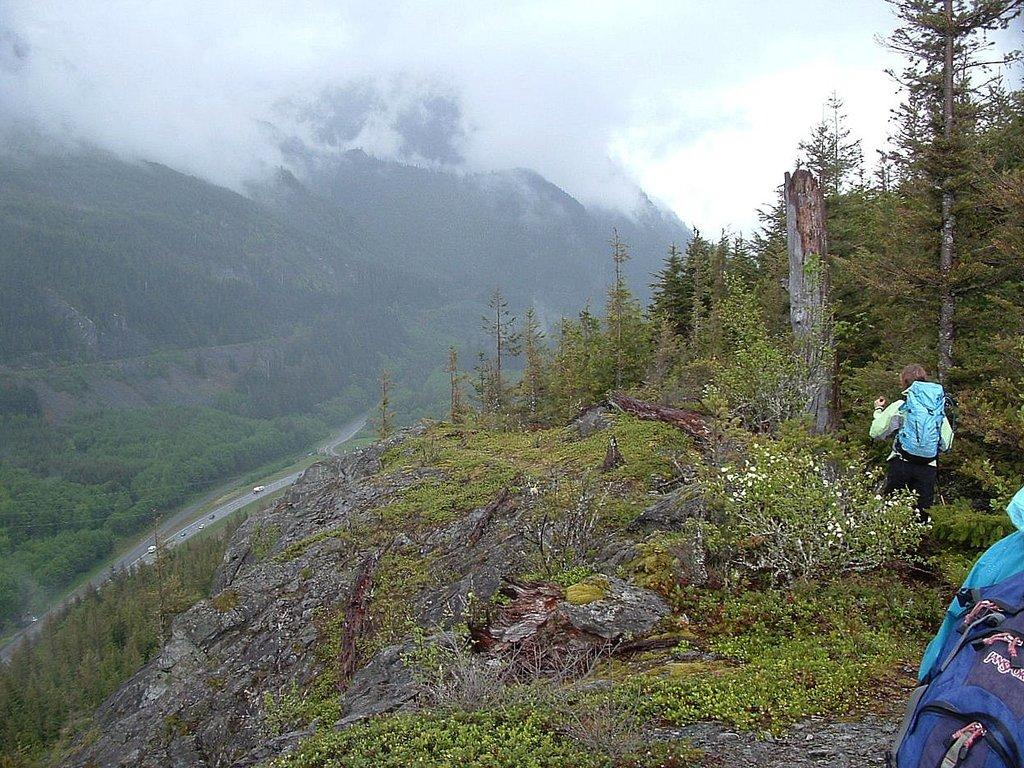What type of vegetation can be seen on the hills in the image? There are trees on the hills in the image. What are the people in the image carrying? The people in the image are carrying backpacks. What atmospheric condition is present in the image? There appears to be fog in the image. How would you describe the sky in the image? The sky is cloudy in the image. How many pizzas are being carried by the people in the image? There are no pizzas present in the image; the people are carrying backpacks. Can you describe the frogs' behavior in the image? There are no frogs present in the image. 